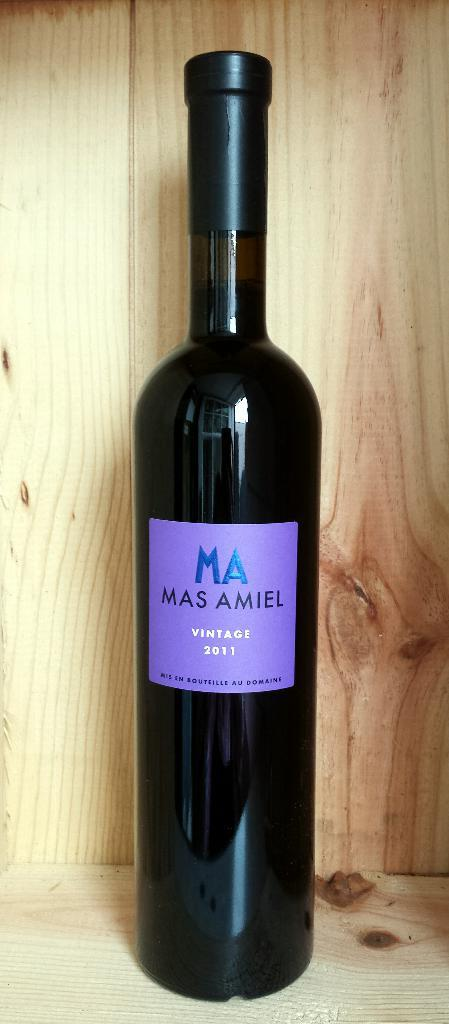<image>
Create a compact narrative representing the image presented. A bottle of red wine with the letters MA on it in blue 